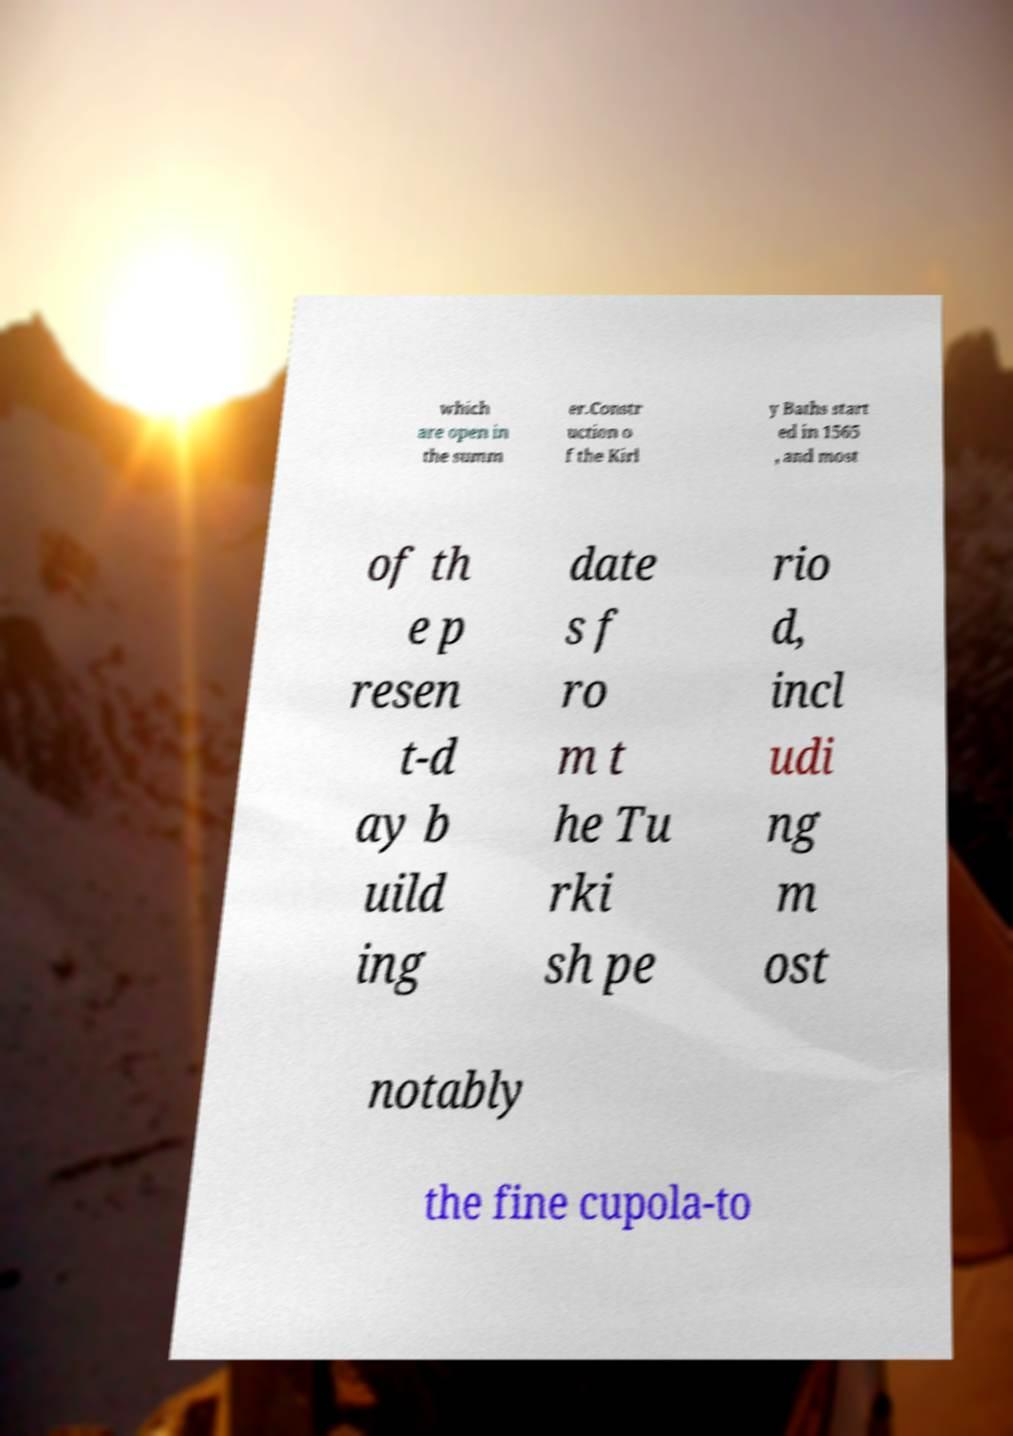There's text embedded in this image that I need extracted. Can you transcribe it verbatim? which are open in the summ er.Constr uction o f the Kirl y Baths start ed in 1565 , and most of th e p resen t-d ay b uild ing date s f ro m t he Tu rki sh pe rio d, incl udi ng m ost notably the fine cupola-to 